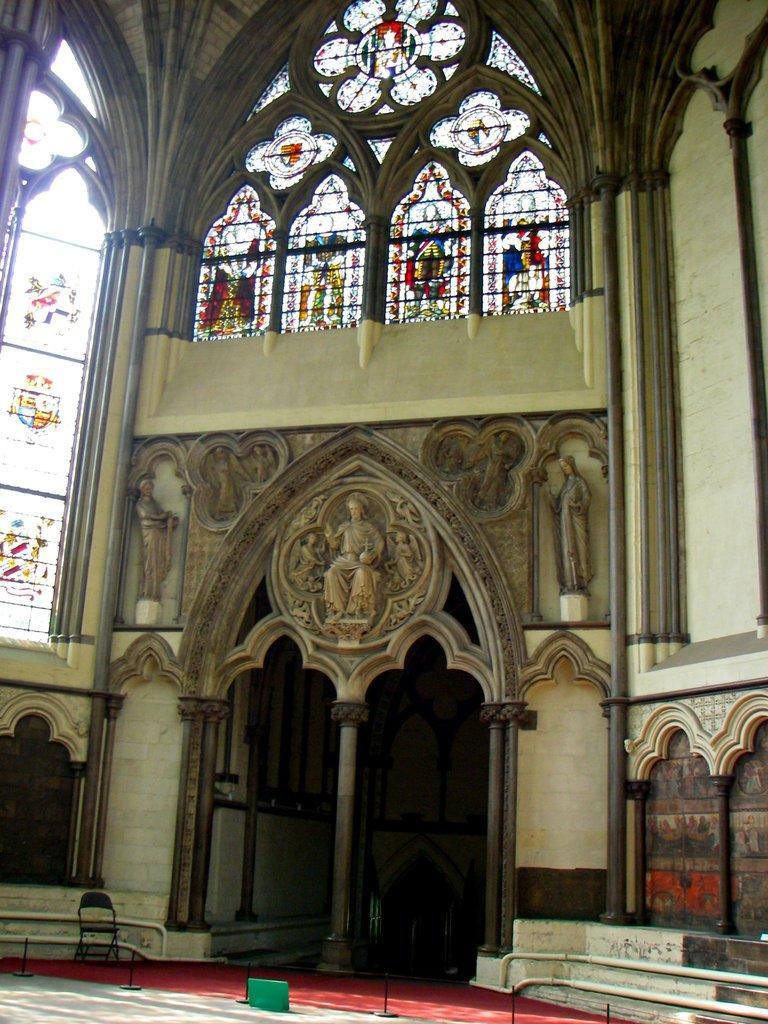How would you summarize this image in a sentence or two? To the bottom of the image there is a floor with red carpet. On the carpet to the left side there is a chair. And in the background there is a room with pillars, walls, sculptures, glass windows and walls. And to the bottom of the walls there are pipes. 